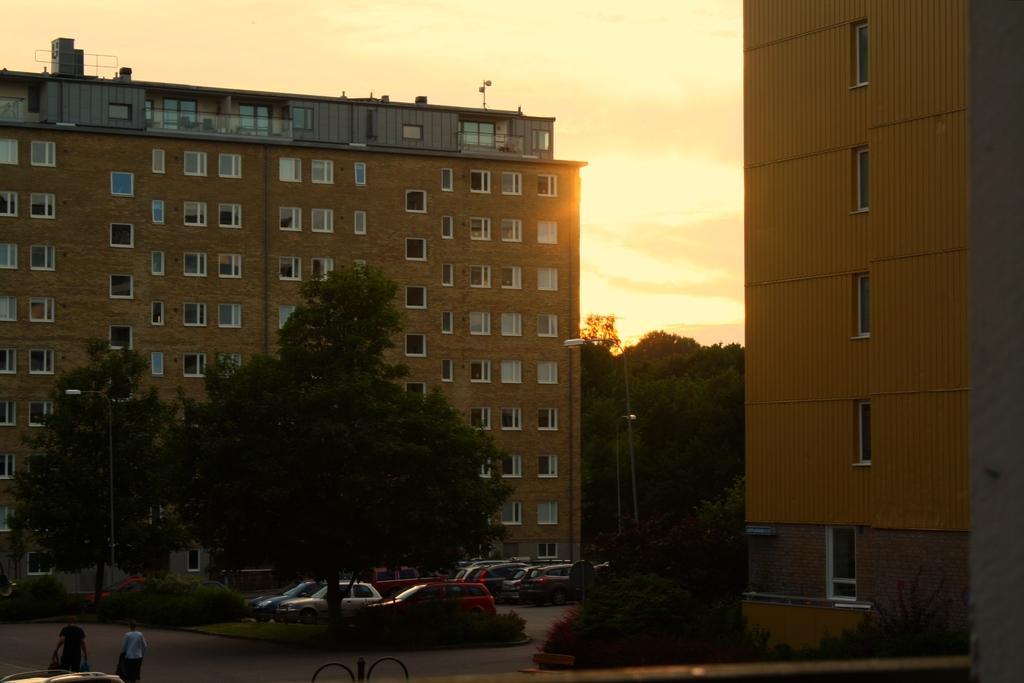Can you describe this image briefly? There are two buildings,the first building has a lot of windows and in front of the building many cars are parked in the parking area and there are a lot of trees around that place,two people are walking on the road in front of the parking area. 